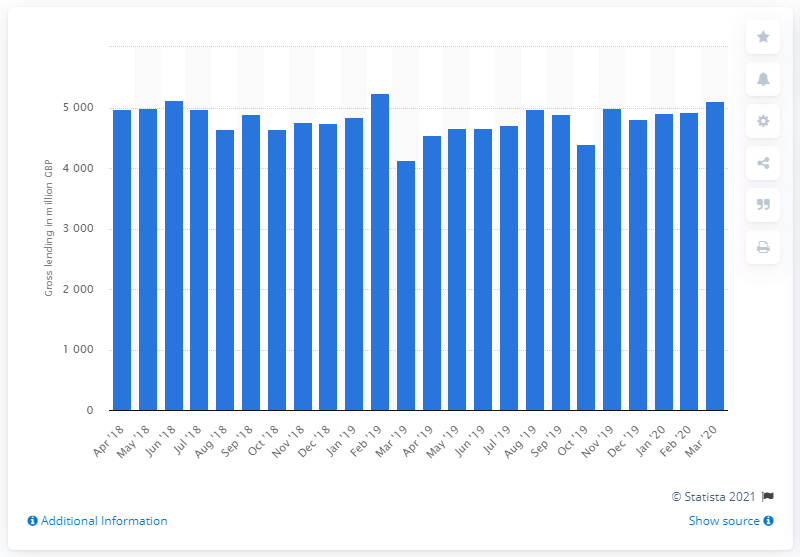Identify some key points in this picture. The value of gross lending between April 2018 and March 2020 was 5102. 